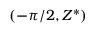<formula> <loc_0><loc_0><loc_500><loc_500>( - \pi / 2 , Z ^ { * } )</formula> 